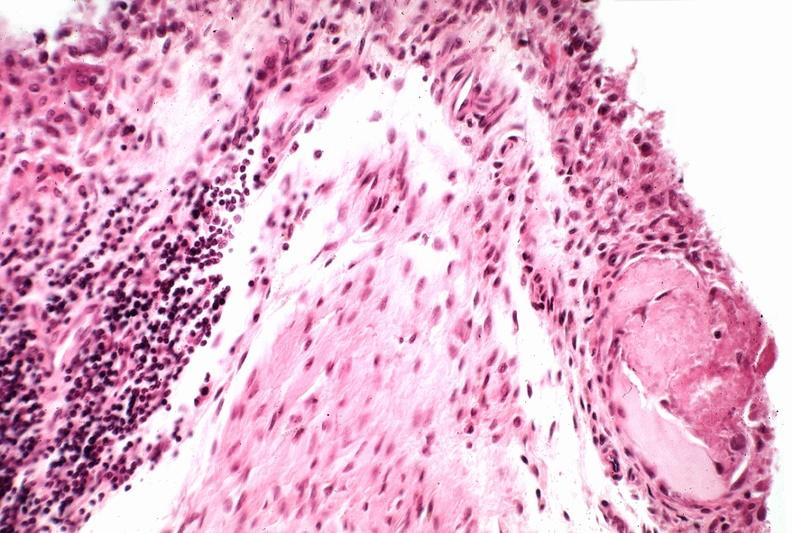does this image show synovial proliferation, villous, rheumatoid arthritis?
Answer the question using a single word or phrase. Yes 